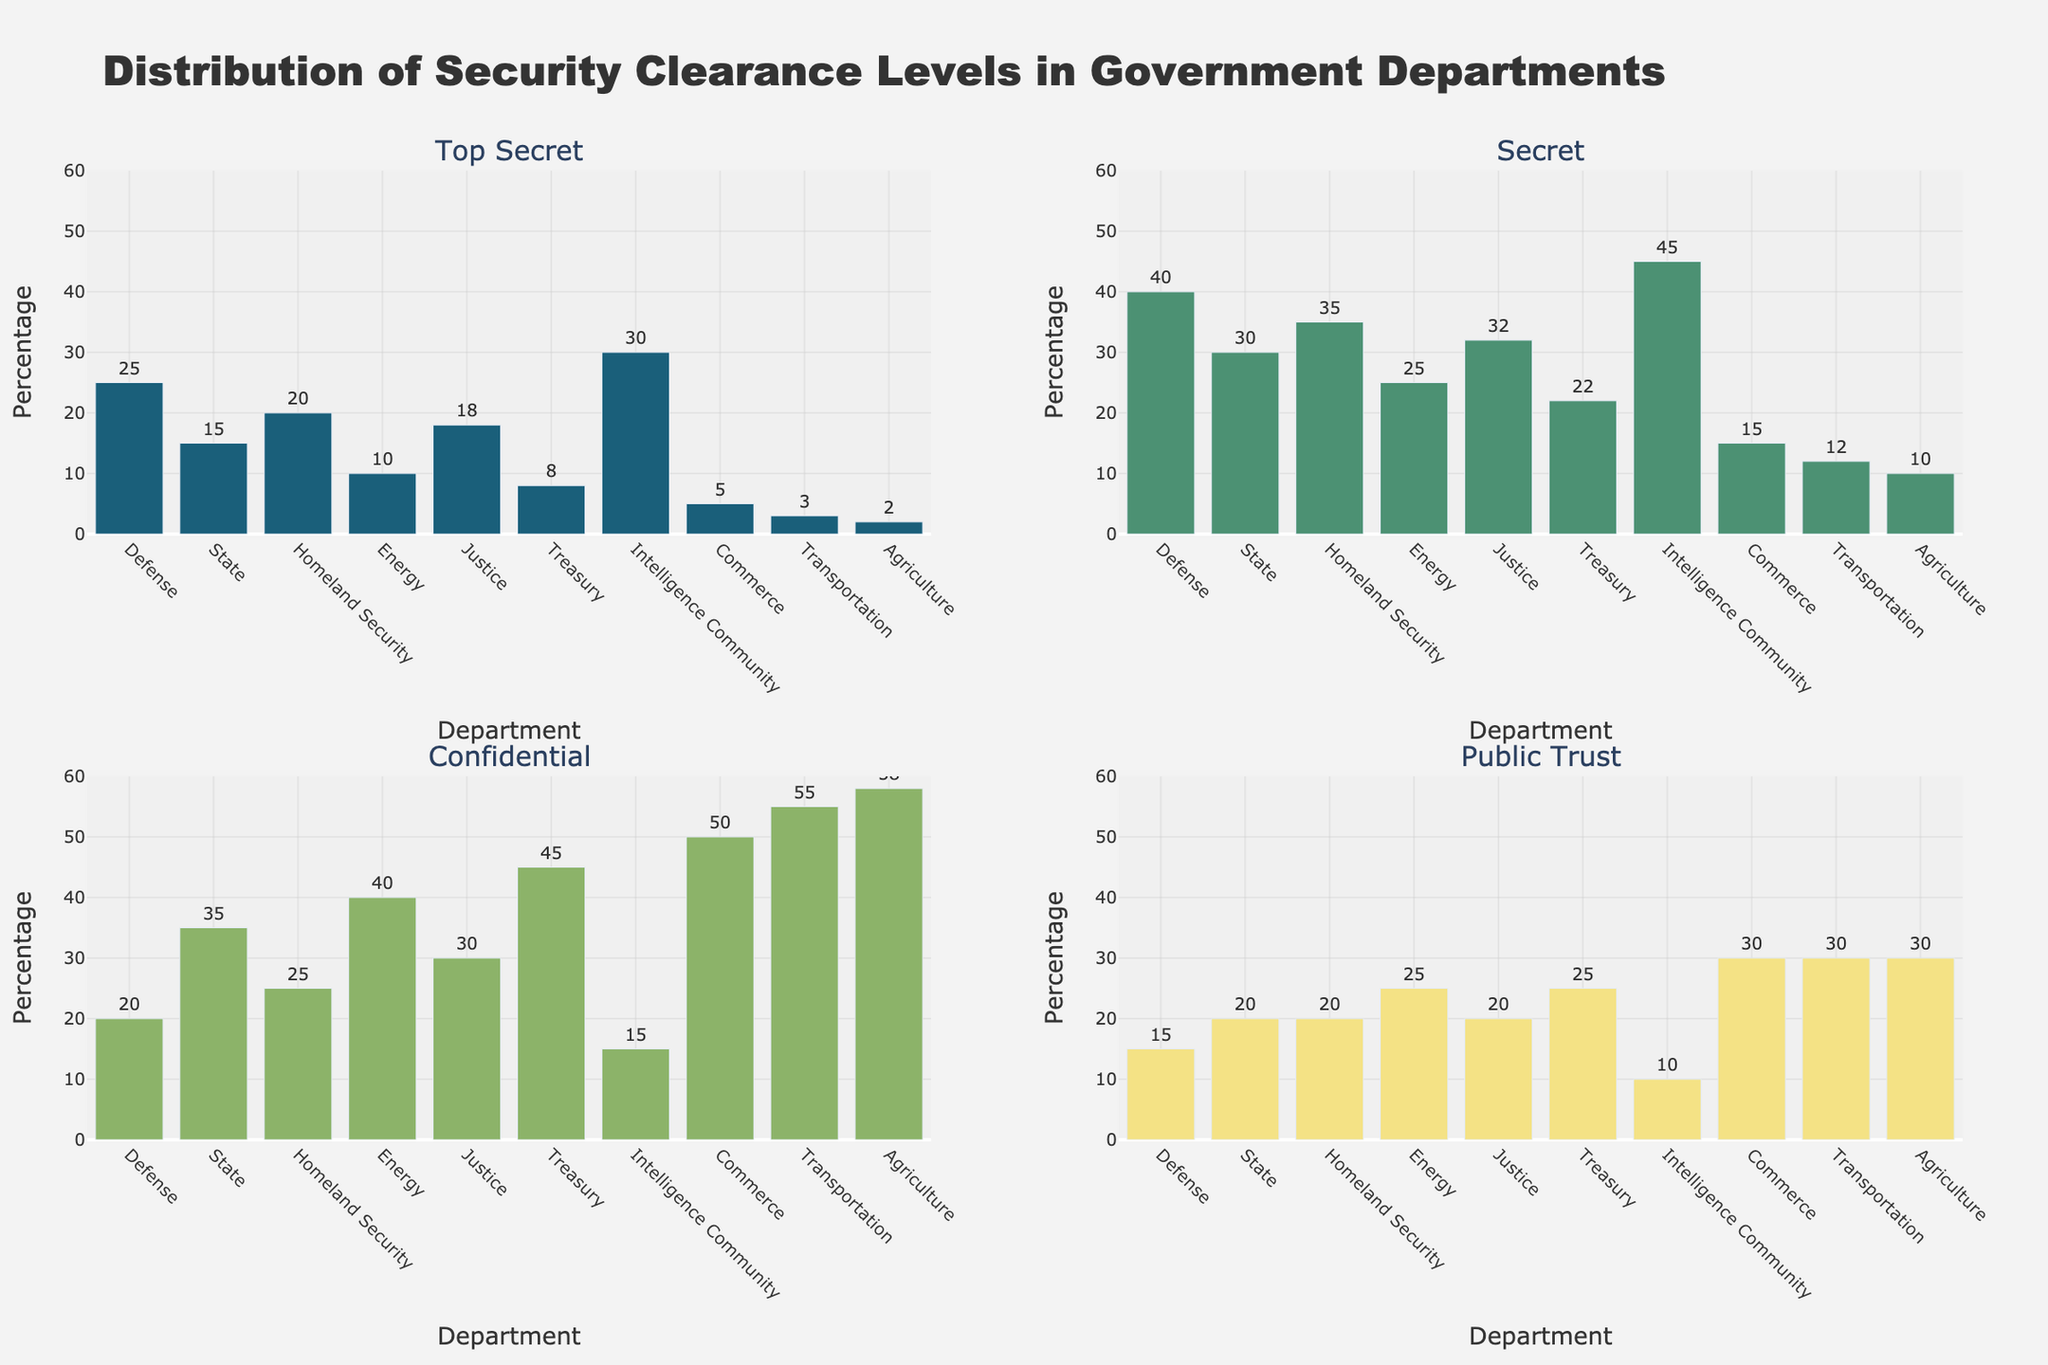What is the trend for the number of Chinese students in US universities from 2018 to 2022? The number of Chinese students fluctuated between 2018 and 2022. It peaked in 2020 and then declined sharply in 2021 and 2022.
Answer: Peaked in 2020, declined in 2021 and 2022 Which country saw the largest increase in international students from 2021 to 2022? Compare the number of students from all countries between 2021 and 2022. The numbers for India increased from 167,582 in 2021 to 199,182 in 2022, which is the largest increase.
Answer: India How many students from Brazil were studying in US universities in 2019? Locate the subplot for Brazil and read the value for the year 2019. The value is approximately 16,059 students.
Answer: 16,059 Which country had the most stable number of students in the US from 2018 to 2022? Examine each subplot and check which country had the least fluctuation in numbers over the years. South Korea had the most stable numbers with slight declines over the years.
Answer: South Korea What was the approximate number of Saudi Arabian students in US universities in 2022? Locate the subplot for Saudi Arabia and look for the point representing the year 2022. The number is about 27,347 students.
Answer: 27,347 Compare the trend of Indian and Chinese students from 2018 to 2022. For India, student numbers slightly decreased from 2018 to 2020, declined in 2021, and then increased in 2022. For China, it peaked in 2020 and then significantly dropped in 2021 and 2022. India's trend shows a recovery in 2022 while China's shows a consistent decline after the peak.
Answer: India's numbers decreased then increased in 2022, China's numbers peaked in 2020 then declined Which country experienced a downward trend in student numbers every year from 2018 to 2022? Look at each subplot to identify any country with a consistent downward trend each year. Saudi Arabia shows a steady decline every year from 2018 to 2022.
Answer: Saudi Arabia How did the number of South Korean students change from 2020 to 2021? Locate the subplot for South Korea and compare the values for 2020 and 2021. The number decreased from 49,809 in 2020 to 39,491 in 2021.
Answer: Decreased What is the difference in the number of Taiwanese students between 2019 and 2022? Subtract the value of Taiwanese students in 2022 from that in 2019: 23,369 (2019) - 20,993 (2022) = 2,376 students.
Answer: 2,376 Among China, India, and South Korea, which country had the highest number of students in 2022? Compare the values for the year 2022 in the subplots for China, India, and South Korea. China had approximately 290,086, India had 199,182, and South Korea had 40,755. China had the highest number.
Answer: China 